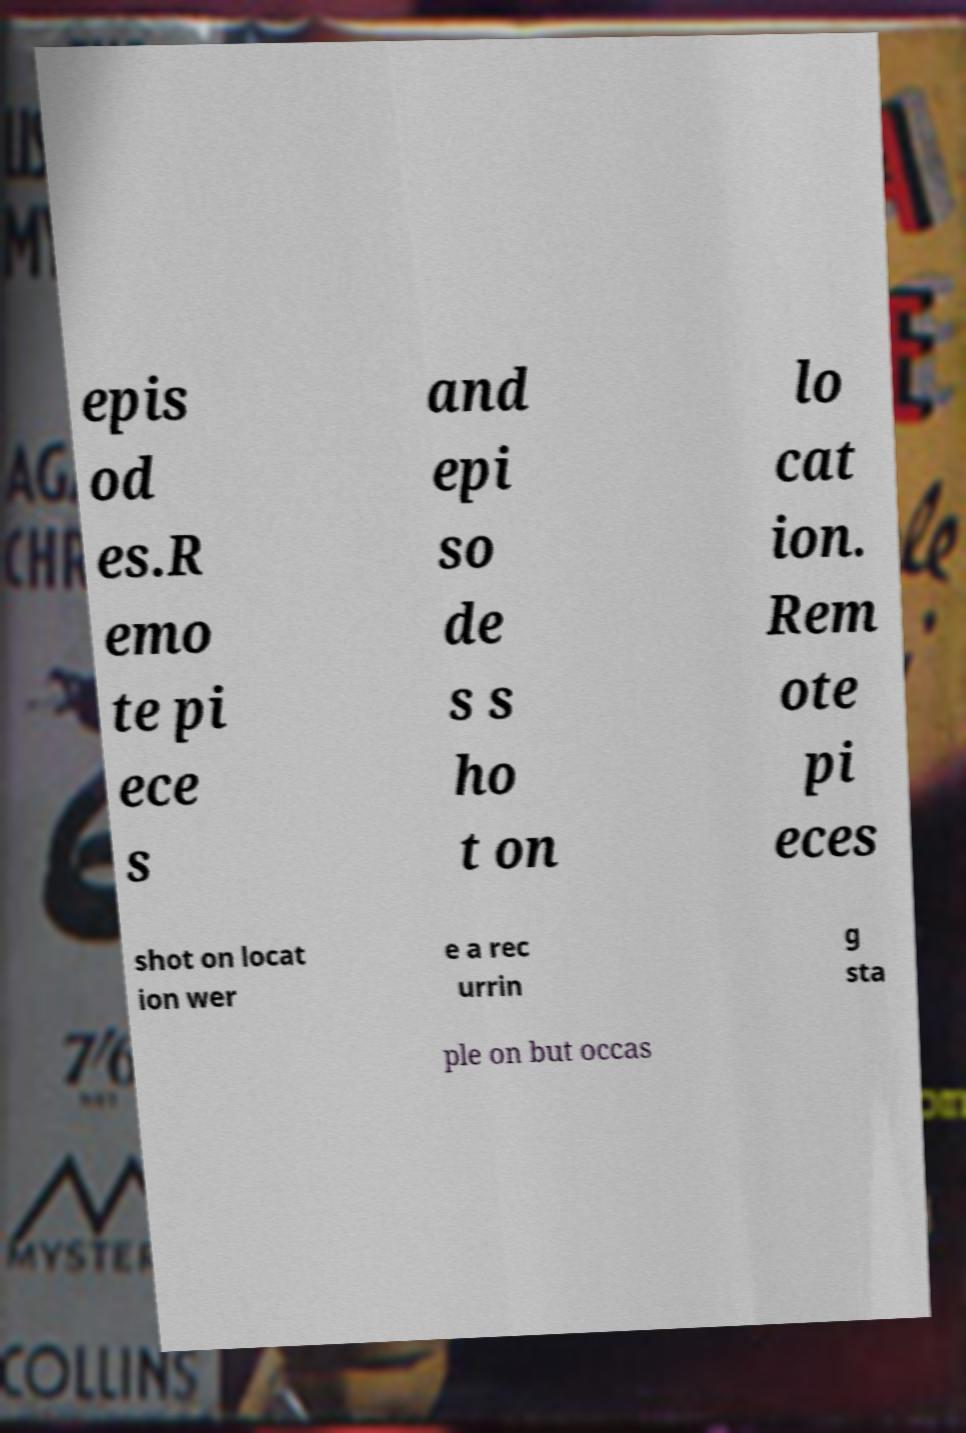Could you extract and type out the text from this image? epis od es.R emo te pi ece s and epi so de s s ho t on lo cat ion. Rem ote pi eces shot on locat ion wer e a rec urrin g sta ple on but occas 